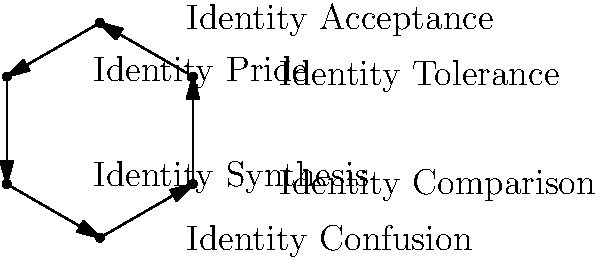The diagram illustrates Cass's model of sexual identity formation. Which stage is characterized by a growing acceptance of the possibility of being LGBTQ+ and seeking out information about sexual orientation? To answer this question, let's examine Cass's model of sexual identity formation step by step:

1. Identity Confusion: Initial awareness of LGBTQ+ thoughts or feelings, often accompanied by denial or confusion.

2. Identity Comparison: Beginning to accept the possibility of being LGBTQ+. This stage involves seeking information about sexual orientation and comparing oneself to others.

3. Identity Tolerance: Acknowledging one's LGBTQ+ identity and beginning to tolerate it, often still maintaining a heterosexual public image.

4. Identity Acceptance: Positive acceptance of one's LGBTQ+ identity and increased contact with LGBTQ+ community.

5. Identity Pride: Strong alignment with LGBTQ+ community and possible rejection of heterosexual values.

6. Identity Synthesis: Integration of LGBTQ+ identity with other aspects of self, recognizing similarities with heterosexuals.

The stage that best fits the description in the question is Identity Comparison. This stage is characterized by individuals beginning to accept the possibility of being LGBTQ+ and actively seeking information about sexual orientation to better understand themselves.
Answer: Identity Comparison 